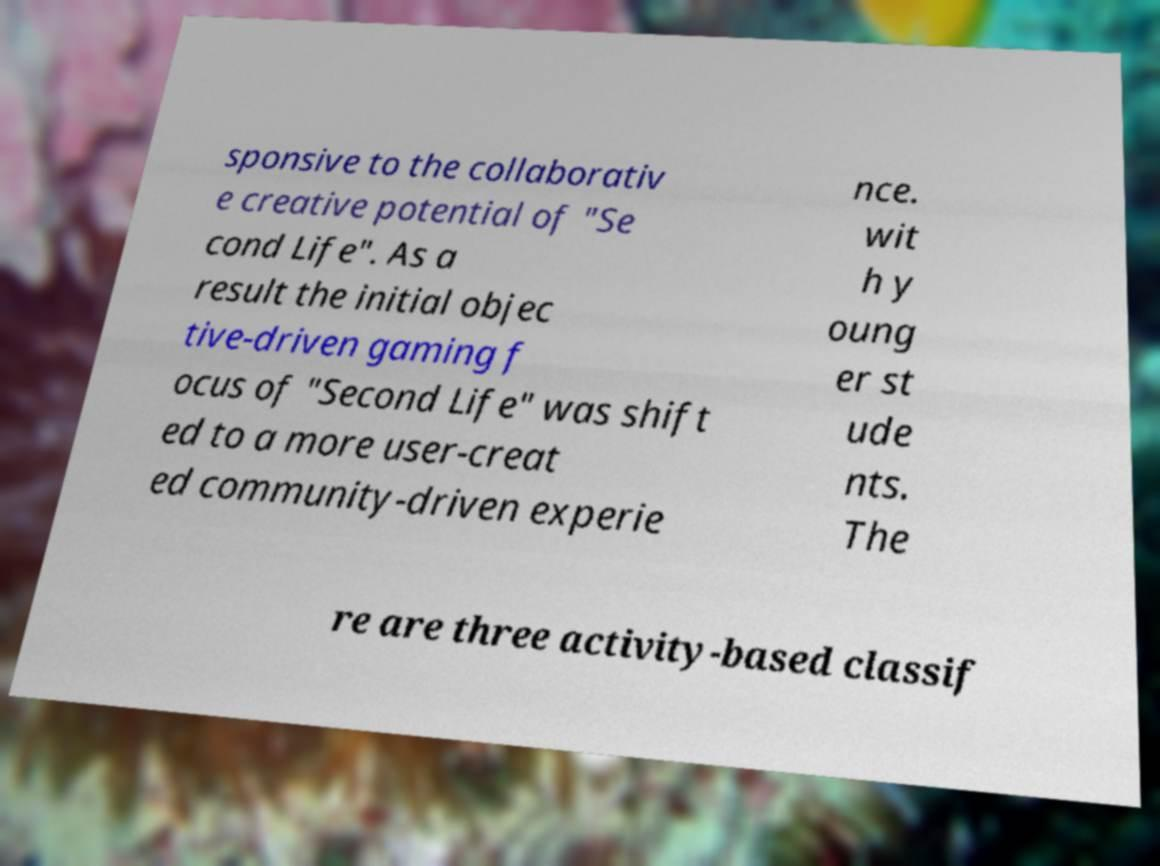What messages or text are displayed in this image? I need them in a readable, typed format. sponsive to the collaborativ e creative potential of "Se cond Life". As a result the initial objec tive-driven gaming f ocus of "Second Life" was shift ed to a more user-creat ed community-driven experie nce. wit h y oung er st ude nts. The re are three activity-based classif 